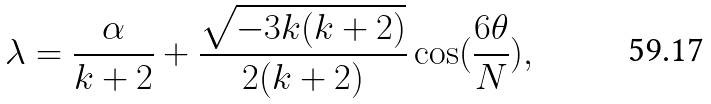Convert formula to latex. <formula><loc_0><loc_0><loc_500><loc_500>\lambda = \frac { \alpha } { k + 2 } + \frac { \sqrt { - 3 k ( k + 2 ) } } { 2 ( k + 2 ) } \cos ( \frac { 6 \theta } { N } ) ,</formula> 